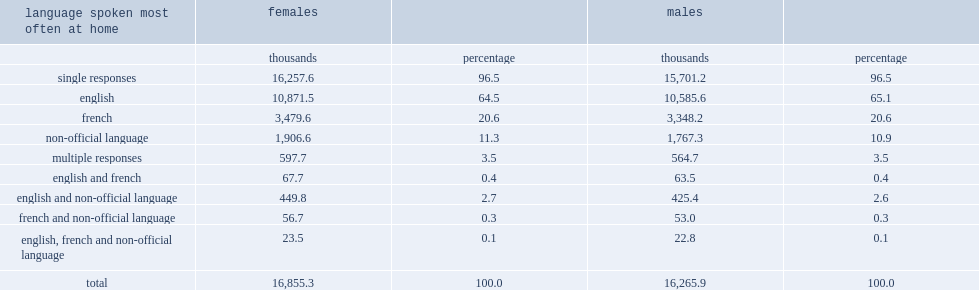In 2011, how many women and girls reported that they spoke more than one language most often at home? 597.7. In 2011, what was the percentage of women and girls reported that they spoke more than one language most often at home? 3.5. 